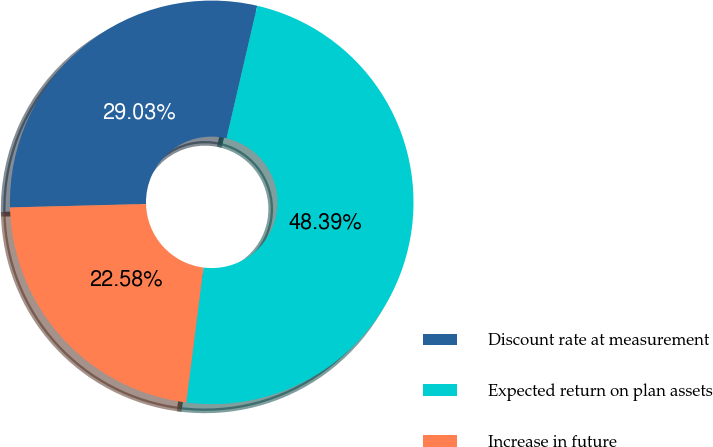<chart> <loc_0><loc_0><loc_500><loc_500><pie_chart><fcel>Discount rate at measurement<fcel>Expected return on plan assets<fcel>Increase in future<nl><fcel>29.03%<fcel>48.39%<fcel>22.58%<nl></chart> 